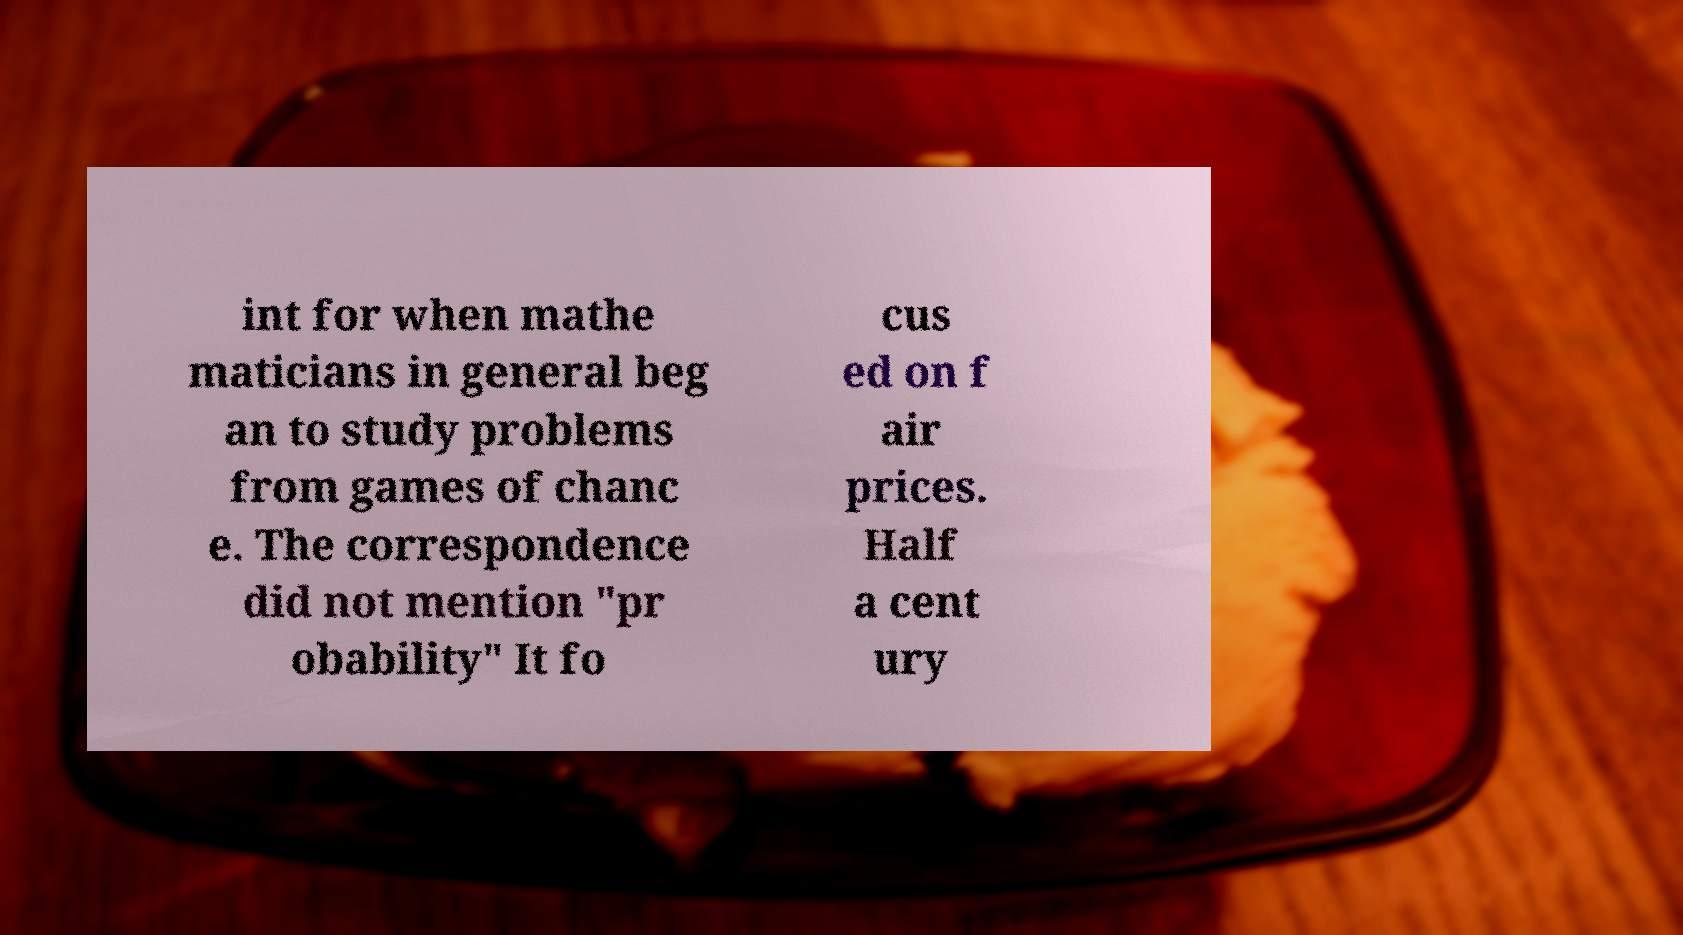Please read and relay the text visible in this image. What does it say? int for when mathe maticians in general beg an to study problems from games of chanc e. The correspondence did not mention "pr obability" It fo cus ed on f air prices. Half a cent ury 